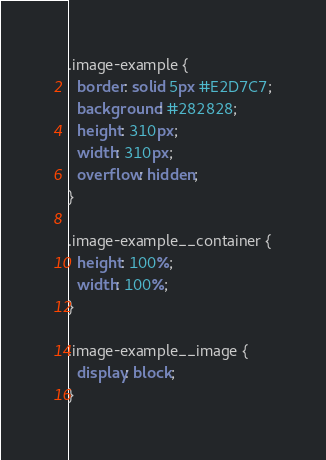Convert code to text. <code><loc_0><loc_0><loc_500><loc_500><_CSS_>.image-example {
  border: solid 5px #E2D7C7;
  background: #282828;
  height: 310px;
  width: 310px;
  overflow: hidden;
}

.image-example__container {
  height: 100%;
  width: 100%;
}

.image-example__image {
  display: block;
}
</code> 